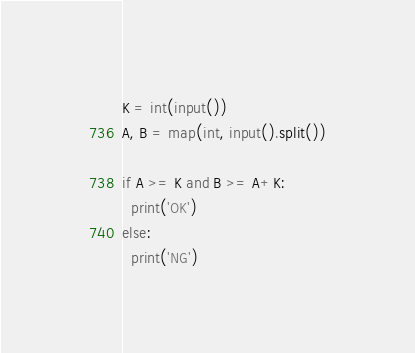<code> <loc_0><loc_0><loc_500><loc_500><_Python_>K = int(input())
A, B = map(int, input().split())

if A >= K and B >= A+K:
  print('OK')
else:
  print('NG')</code> 